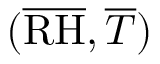<formula> <loc_0><loc_0><loc_500><loc_500>( \overline { R H } , \overline { T } )</formula> 